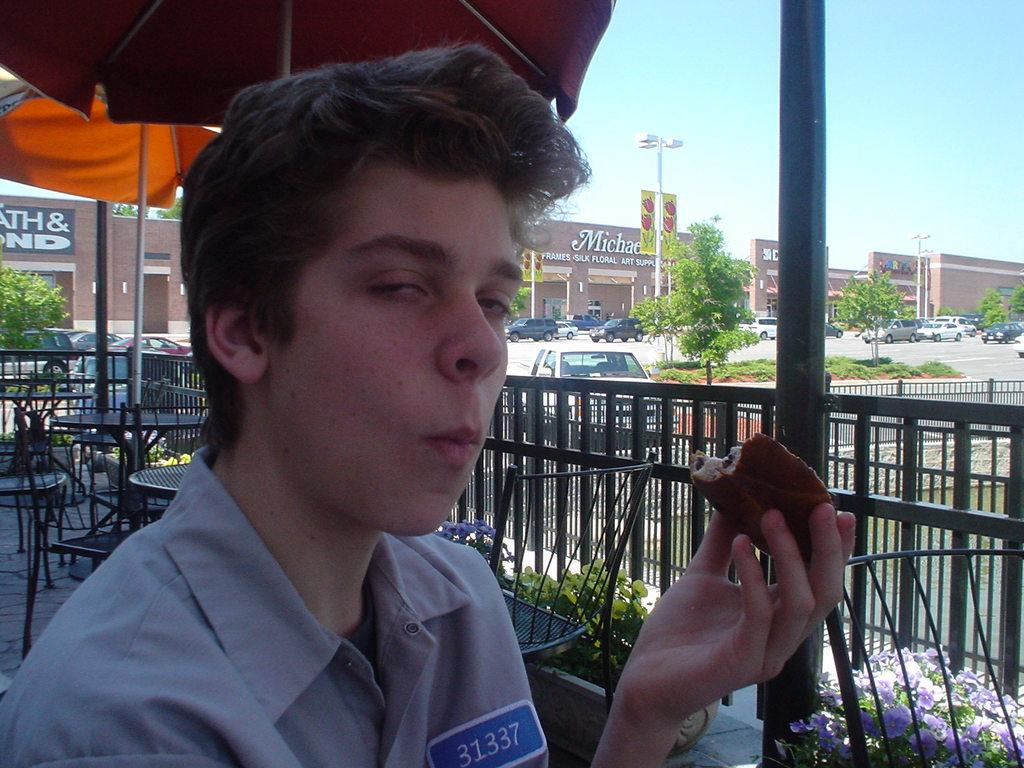<image>
Provide a brief description of the given image. A man chews food while there is a Michaels frames, silk, and floral store in the background. 